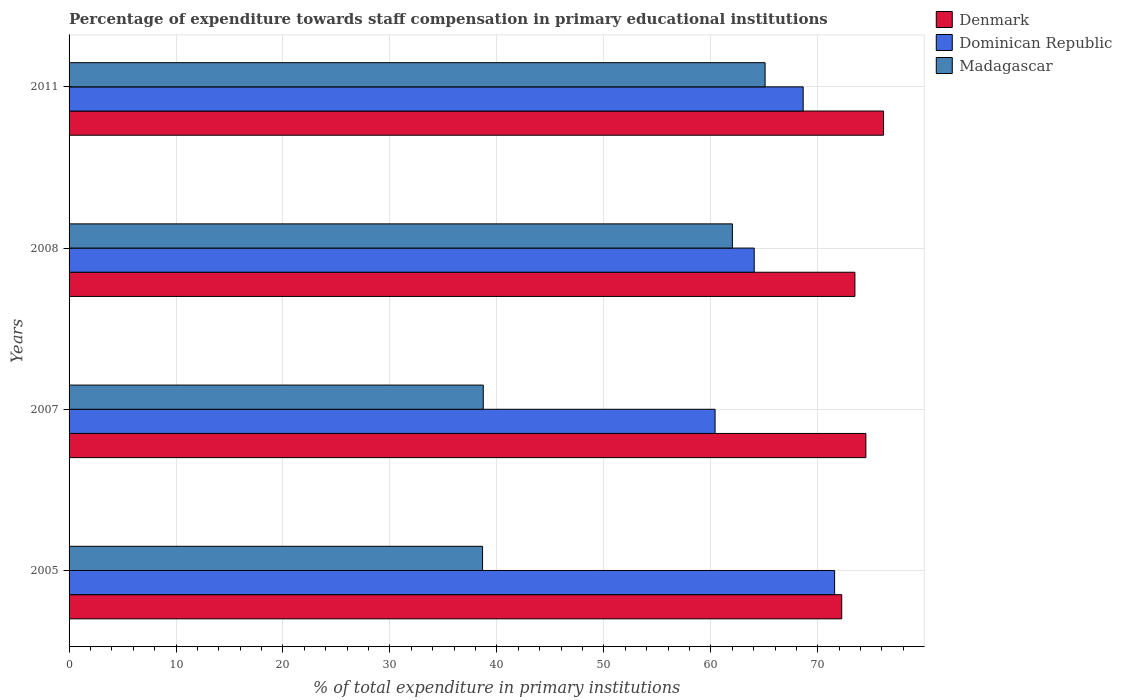Are the number of bars per tick equal to the number of legend labels?
Provide a succinct answer. Yes. Are the number of bars on each tick of the Y-axis equal?
Give a very brief answer. Yes. How many bars are there on the 2nd tick from the bottom?
Keep it short and to the point. 3. What is the label of the 4th group of bars from the top?
Give a very brief answer. 2005. In how many cases, is the number of bars for a given year not equal to the number of legend labels?
Make the answer very short. 0. What is the percentage of expenditure towards staff compensation in Dominican Republic in 2008?
Give a very brief answer. 64.06. Across all years, what is the maximum percentage of expenditure towards staff compensation in Denmark?
Ensure brevity in your answer.  76.15. Across all years, what is the minimum percentage of expenditure towards staff compensation in Dominican Republic?
Keep it short and to the point. 60.4. In which year was the percentage of expenditure towards staff compensation in Denmark maximum?
Your response must be concise. 2011. In which year was the percentage of expenditure towards staff compensation in Denmark minimum?
Your answer should be very brief. 2005. What is the total percentage of expenditure towards staff compensation in Madagascar in the graph?
Offer a terse response. 204.47. What is the difference between the percentage of expenditure towards staff compensation in Madagascar in 2005 and that in 2008?
Provide a short and direct response. -23.36. What is the difference between the percentage of expenditure towards staff compensation in Madagascar in 2005 and the percentage of expenditure towards staff compensation in Dominican Republic in 2007?
Provide a short and direct response. -21.74. What is the average percentage of expenditure towards staff compensation in Madagascar per year?
Keep it short and to the point. 51.12. In the year 2011, what is the difference between the percentage of expenditure towards staff compensation in Madagascar and percentage of expenditure towards staff compensation in Denmark?
Make the answer very short. -11.07. In how many years, is the percentage of expenditure towards staff compensation in Madagascar greater than 50 %?
Your response must be concise. 2. What is the ratio of the percentage of expenditure towards staff compensation in Dominican Republic in 2007 to that in 2011?
Make the answer very short. 0.88. Is the percentage of expenditure towards staff compensation in Dominican Republic in 2007 less than that in 2011?
Keep it short and to the point. Yes. Is the difference between the percentage of expenditure towards staff compensation in Madagascar in 2007 and 2011 greater than the difference between the percentage of expenditure towards staff compensation in Denmark in 2007 and 2011?
Provide a short and direct response. No. What is the difference between the highest and the second highest percentage of expenditure towards staff compensation in Madagascar?
Make the answer very short. 3.06. What is the difference between the highest and the lowest percentage of expenditure towards staff compensation in Madagascar?
Ensure brevity in your answer.  26.41. In how many years, is the percentage of expenditure towards staff compensation in Denmark greater than the average percentage of expenditure towards staff compensation in Denmark taken over all years?
Make the answer very short. 2. Is the sum of the percentage of expenditure towards staff compensation in Denmark in 2007 and 2008 greater than the maximum percentage of expenditure towards staff compensation in Dominican Republic across all years?
Provide a succinct answer. Yes. What does the 2nd bar from the top in 2005 represents?
Keep it short and to the point. Dominican Republic. What does the 2nd bar from the bottom in 2005 represents?
Your answer should be very brief. Dominican Republic. Is it the case that in every year, the sum of the percentage of expenditure towards staff compensation in Denmark and percentage of expenditure towards staff compensation in Madagascar is greater than the percentage of expenditure towards staff compensation in Dominican Republic?
Ensure brevity in your answer.  Yes. Are the values on the major ticks of X-axis written in scientific E-notation?
Offer a terse response. No. Where does the legend appear in the graph?
Make the answer very short. Top right. How many legend labels are there?
Provide a succinct answer. 3. How are the legend labels stacked?
Provide a short and direct response. Vertical. What is the title of the graph?
Keep it short and to the point. Percentage of expenditure towards staff compensation in primary educational institutions. What is the label or title of the X-axis?
Give a very brief answer. % of total expenditure in primary institutions. What is the label or title of the Y-axis?
Your answer should be compact. Years. What is the % of total expenditure in primary institutions of Denmark in 2005?
Keep it short and to the point. 72.24. What is the % of total expenditure in primary institutions in Dominican Republic in 2005?
Your response must be concise. 71.57. What is the % of total expenditure in primary institutions in Madagascar in 2005?
Provide a succinct answer. 38.66. What is the % of total expenditure in primary institutions in Denmark in 2007?
Offer a terse response. 74.5. What is the % of total expenditure in primary institutions in Dominican Republic in 2007?
Offer a terse response. 60.4. What is the % of total expenditure in primary institutions in Madagascar in 2007?
Offer a very short reply. 38.72. What is the % of total expenditure in primary institutions of Denmark in 2008?
Provide a short and direct response. 73.47. What is the % of total expenditure in primary institutions of Dominican Republic in 2008?
Provide a succinct answer. 64.06. What is the % of total expenditure in primary institutions in Madagascar in 2008?
Ensure brevity in your answer.  62.02. What is the % of total expenditure in primary institutions of Denmark in 2011?
Give a very brief answer. 76.15. What is the % of total expenditure in primary institutions in Dominican Republic in 2011?
Your response must be concise. 68.63. What is the % of total expenditure in primary institutions of Madagascar in 2011?
Give a very brief answer. 65.07. Across all years, what is the maximum % of total expenditure in primary institutions of Denmark?
Your answer should be very brief. 76.15. Across all years, what is the maximum % of total expenditure in primary institutions of Dominican Republic?
Provide a succinct answer. 71.57. Across all years, what is the maximum % of total expenditure in primary institutions of Madagascar?
Make the answer very short. 65.07. Across all years, what is the minimum % of total expenditure in primary institutions of Denmark?
Provide a short and direct response. 72.24. Across all years, what is the minimum % of total expenditure in primary institutions of Dominican Republic?
Offer a very short reply. 60.4. Across all years, what is the minimum % of total expenditure in primary institutions in Madagascar?
Ensure brevity in your answer.  38.66. What is the total % of total expenditure in primary institutions of Denmark in the graph?
Make the answer very short. 296.35. What is the total % of total expenditure in primary institutions of Dominican Republic in the graph?
Offer a terse response. 264.66. What is the total % of total expenditure in primary institutions of Madagascar in the graph?
Ensure brevity in your answer.  204.47. What is the difference between the % of total expenditure in primary institutions in Denmark in 2005 and that in 2007?
Ensure brevity in your answer.  -2.26. What is the difference between the % of total expenditure in primary institutions of Dominican Republic in 2005 and that in 2007?
Offer a terse response. 11.18. What is the difference between the % of total expenditure in primary institutions in Madagascar in 2005 and that in 2007?
Your response must be concise. -0.07. What is the difference between the % of total expenditure in primary institutions in Denmark in 2005 and that in 2008?
Your answer should be very brief. -1.23. What is the difference between the % of total expenditure in primary institutions in Dominican Republic in 2005 and that in 2008?
Give a very brief answer. 7.52. What is the difference between the % of total expenditure in primary institutions in Madagascar in 2005 and that in 2008?
Your answer should be compact. -23.36. What is the difference between the % of total expenditure in primary institutions in Denmark in 2005 and that in 2011?
Your answer should be compact. -3.91. What is the difference between the % of total expenditure in primary institutions in Dominican Republic in 2005 and that in 2011?
Provide a succinct answer. 2.94. What is the difference between the % of total expenditure in primary institutions of Madagascar in 2005 and that in 2011?
Provide a short and direct response. -26.41. What is the difference between the % of total expenditure in primary institutions of Denmark in 2007 and that in 2008?
Your answer should be compact. 1.03. What is the difference between the % of total expenditure in primary institutions in Dominican Republic in 2007 and that in 2008?
Give a very brief answer. -3.66. What is the difference between the % of total expenditure in primary institutions in Madagascar in 2007 and that in 2008?
Offer a terse response. -23.29. What is the difference between the % of total expenditure in primary institutions in Denmark in 2007 and that in 2011?
Provide a short and direct response. -1.65. What is the difference between the % of total expenditure in primary institutions of Dominican Republic in 2007 and that in 2011?
Offer a very short reply. -8.24. What is the difference between the % of total expenditure in primary institutions in Madagascar in 2007 and that in 2011?
Give a very brief answer. -26.35. What is the difference between the % of total expenditure in primary institutions of Denmark in 2008 and that in 2011?
Offer a very short reply. -2.68. What is the difference between the % of total expenditure in primary institutions of Dominican Republic in 2008 and that in 2011?
Provide a succinct answer. -4.58. What is the difference between the % of total expenditure in primary institutions in Madagascar in 2008 and that in 2011?
Offer a terse response. -3.06. What is the difference between the % of total expenditure in primary institutions in Denmark in 2005 and the % of total expenditure in primary institutions in Dominican Republic in 2007?
Provide a succinct answer. 11.84. What is the difference between the % of total expenditure in primary institutions of Denmark in 2005 and the % of total expenditure in primary institutions of Madagascar in 2007?
Offer a very short reply. 33.51. What is the difference between the % of total expenditure in primary institutions in Dominican Republic in 2005 and the % of total expenditure in primary institutions in Madagascar in 2007?
Give a very brief answer. 32.85. What is the difference between the % of total expenditure in primary institutions of Denmark in 2005 and the % of total expenditure in primary institutions of Dominican Republic in 2008?
Give a very brief answer. 8.18. What is the difference between the % of total expenditure in primary institutions in Denmark in 2005 and the % of total expenditure in primary institutions in Madagascar in 2008?
Make the answer very short. 10.22. What is the difference between the % of total expenditure in primary institutions of Dominican Republic in 2005 and the % of total expenditure in primary institutions of Madagascar in 2008?
Ensure brevity in your answer.  9.56. What is the difference between the % of total expenditure in primary institutions of Denmark in 2005 and the % of total expenditure in primary institutions of Dominican Republic in 2011?
Give a very brief answer. 3.61. What is the difference between the % of total expenditure in primary institutions of Denmark in 2005 and the % of total expenditure in primary institutions of Madagascar in 2011?
Offer a terse response. 7.16. What is the difference between the % of total expenditure in primary institutions in Dominican Republic in 2005 and the % of total expenditure in primary institutions in Madagascar in 2011?
Offer a terse response. 6.5. What is the difference between the % of total expenditure in primary institutions in Denmark in 2007 and the % of total expenditure in primary institutions in Dominican Republic in 2008?
Keep it short and to the point. 10.44. What is the difference between the % of total expenditure in primary institutions of Denmark in 2007 and the % of total expenditure in primary institutions of Madagascar in 2008?
Your answer should be compact. 12.48. What is the difference between the % of total expenditure in primary institutions in Dominican Republic in 2007 and the % of total expenditure in primary institutions in Madagascar in 2008?
Ensure brevity in your answer.  -1.62. What is the difference between the % of total expenditure in primary institutions of Denmark in 2007 and the % of total expenditure in primary institutions of Dominican Republic in 2011?
Give a very brief answer. 5.86. What is the difference between the % of total expenditure in primary institutions of Denmark in 2007 and the % of total expenditure in primary institutions of Madagascar in 2011?
Offer a terse response. 9.42. What is the difference between the % of total expenditure in primary institutions of Dominican Republic in 2007 and the % of total expenditure in primary institutions of Madagascar in 2011?
Your response must be concise. -4.68. What is the difference between the % of total expenditure in primary institutions of Denmark in 2008 and the % of total expenditure in primary institutions of Dominican Republic in 2011?
Your answer should be very brief. 4.84. What is the difference between the % of total expenditure in primary institutions in Denmark in 2008 and the % of total expenditure in primary institutions in Madagascar in 2011?
Your answer should be compact. 8.4. What is the difference between the % of total expenditure in primary institutions in Dominican Republic in 2008 and the % of total expenditure in primary institutions in Madagascar in 2011?
Your answer should be compact. -1.02. What is the average % of total expenditure in primary institutions of Denmark per year?
Offer a terse response. 74.09. What is the average % of total expenditure in primary institutions in Dominican Republic per year?
Give a very brief answer. 66.16. What is the average % of total expenditure in primary institutions in Madagascar per year?
Provide a short and direct response. 51.12. In the year 2005, what is the difference between the % of total expenditure in primary institutions of Denmark and % of total expenditure in primary institutions of Dominican Republic?
Give a very brief answer. 0.67. In the year 2005, what is the difference between the % of total expenditure in primary institutions in Denmark and % of total expenditure in primary institutions in Madagascar?
Your answer should be compact. 33.58. In the year 2005, what is the difference between the % of total expenditure in primary institutions of Dominican Republic and % of total expenditure in primary institutions of Madagascar?
Make the answer very short. 32.91. In the year 2007, what is the difference between the % of total expenditure in primary institutions of Denmark and % of total expenditure in primary institutions of Dominican Republic?
Offer a very short reply. 14.1. In the year 2007, what is the difference between the % of total expenditure in primary institutions of Denmark and % of total expenditure in primary institutions of Madagascar?
Offer a terse response. 35.77. In the year 2007, what is the difference between the % of total expenditure in primary institutions in Dominican Republic and % of total expenditure in primary institutions in Madagascar?
Ensure brevity in your answer.  21.67. In the year 2008, what is the difference between the % of total expenditure in primary institutions of Denmark and % of total expenditure in primary institutions of Dominican Republic?
Offer a very short reply. 9.41. In the year 2008, what is the difference between the % of total expenditure in primary institutions in Denmark and % of total expenditure in primary institutions in Madagascar?
Give a very brief answer. 11.45. In the year 2008, what is the difference between the % of total expenditure in primary institutions in Dominican Republic and % of total expenditure in primary institutions in Madagascar?
Your answer should be compact. 2.04. In the year 2011, what is the difference between the % of total expenditure in primary institutions in Denmark and % of total expenditure in primary institutions in Dominican Republic?
Provide a short and direct response. 7.51. In the year 2011, what is the difference between the % of total expenditure in primary institutions of Denmark and % of total expenditure in primary institutions of Madagascar?
Provide a short and direct response. 11.07. In the year 2011, what is the difference between the % of total expenditure in primary institutions in Dominican Republic and % of total expenditure in primary institutions in Madagascar?
Give a very brief answer. 3.56. What is the ratio of the % of total expenditure in primary institutions in Denmark in 2005 to that in 2007?
Make the answer very short. 0.97. What is the ratio of the % of total expenditure in primary institutions in Dominican Republic in 2005 to that in 2007?
Give a very brief answer. 1.19. What is the ratio of the % of total expenditure in primary institutions in Madagascar in 2005 to that in 2007?
Provide a succinct answer. 1. What is the ratio of the % of total expenditure in primary institutions of Denmark in 2005 to that in 2008?
Keep it short and to the point. 0.98. What is the ratio of the % of total expenditure in primary institutions of Dominican Republic in 2005 to that in 2008?
Keep it short and to the point. 1.12. What is the ratio of the % of total expenditure in primary institutions in Madagascar in 2005 to that in 2008?
Make the answer very short. 0.62. What is the ratio of the % of total expenditure in primary institutions in Denmark in 2005 to that in 2011?
Provide a short and direct response. 0.95. What is the ratio of the % of total expenditure in primary institutions in Dominican Republic in 2005 to that in 2011?
Make the answer very short. 1.04. What is the ratio of the % of total expenditure in primary institutions in Madagascar in 2005 to that in 2011?
Provide a short and direct response. 0.59. What is the ratio of the % of total expenditure in primary institutions in Denmark in 2007 to that in 2008?
Ensure brevity in your answer.  1.01. What is the ratio of the % of total expenditure in primary institutions of Dominican Republic in 2007 to that in 2008?
Offer a terse response. 0.94. What is the ratio of the % of total expenditure in primary institutions of Madagascar in 2007 to that in 2008?
Make the answer very short. 0.62. What is the ratio of the % of total expenditure in primary institutions in Denmark in 2007 to that in 2011?
Offer a terse response. 0.98. What is the ratio of the % of total expenditure in primary institutions of Dominican Republic in 2007 to that in 2011?
Provide a succinct answer. 0.88. What is the ratio of the % of total expenditure in primary institutions in Madagascar in 2007 to that in 2011?
Your response must be concise. 0.6. What is the ratio of the % of total expenditure in primary institutions in Denmark in 2008 to that in 2011?
Give a very brief answer. 0.96. What is the ratio of the % of total expenditure in primary institutions of Dominican Republic in 2008 to that in 2011?
Ensure brevity in your answer.  0.93. What is the ratio of the % of total expenditure in primary institutions in Madagascar in 2008 to that in 2011?
Offer a terse response. 0.95. What is the difference between the highest and the second highest % of total expenditure in primary institutions in Denmark?
Offer a very short reply. 1.65. What is the difference between the highest and the second highest % of total expenditure in primary institutions in Dominican Republic?
Offer a terse response. 2.94. What is the difference between the highest and the second highest % of total expenditure in primary institutions in Madagascar?
Keep it short and to the point. 3.06. What is the difference between the highest and the lowest % of total expenditure in primary institutions of Denmark?
Give a very brief answer. 3.91. What is the difference between the highest and the lowest % of total expenditure in primary institutions of Dominican Republic?
Give a very brief answer. 11.18. What is the difference between the highest and the lowest % of total expenditure in primary institutions of Madagascar?
Your response must be concise. 26.41. 